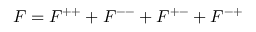<formula> <loc_0><loc_0><loc_500><loc_500>F = F ^ { + + } + F ^ { - - } + F ^ { + - } + F ^ { - + }</formula> 